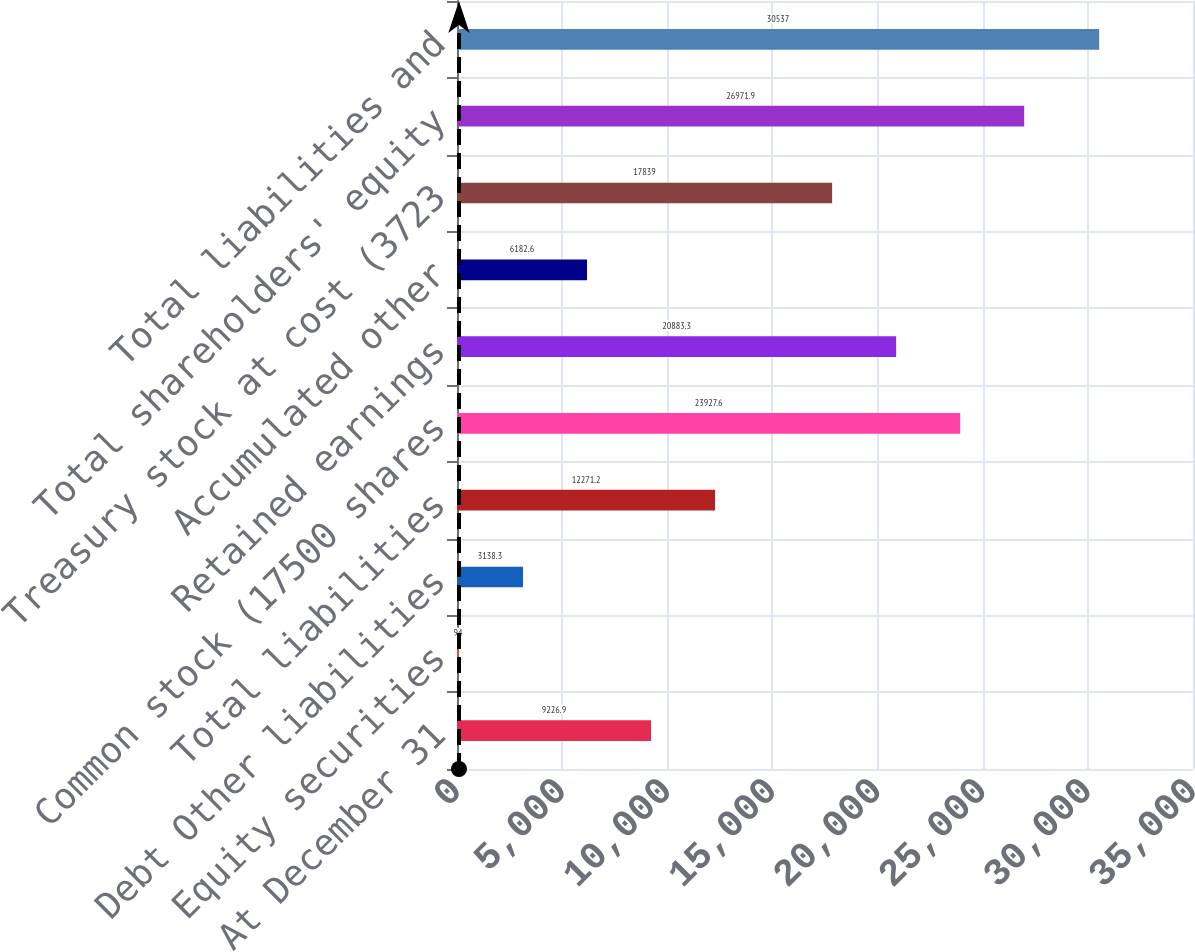Convert chart to OTSL. <chart><loc_0><loc_0><loc_500><loc_500><bar_chart><fcel>At December 31<fcel>Equity securities<fcel>Debt Other liabilities<fcel>Total liabilities<fcel>Common stock (17500 shares<fcel>Retained earnings<fcel>Accumulated other<fcel>Treasury stock at cost (3723<fcel>Total shareholders' equity<fcel>Total liabilities and<nl><fcel>9226.9<fcel>94<fcel>3138.3<fcel>12271.2<fcel>23927.6<fcel>20883.3<fcel>6182.6<fcel>17839<fcel>26971.9<fcel>30537<nl></chart> 